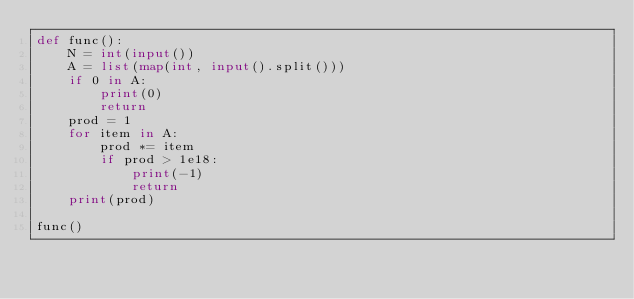<code> <loc_0><loc_0><loc_500><loc_500><_Python_>def func():
    N = int(input())
    A = list(map(int, input().split()))
    if 0 in A:
        print(0)
        return
    prod = 1
    for item in A:
        prod *= item
        if prod > 1e18:
            print(-1)
            return
    print(prod)

func()</code> 